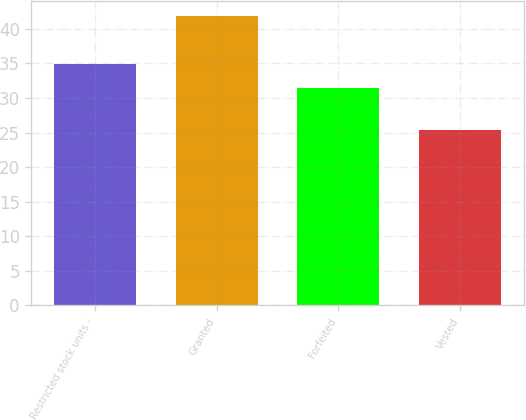Convert chart to OTSL. <chart><loc_0><loc_0><loc_500><loc_500><bar_chart><fcel>Restricted stock units -<fcel>Granted<fcel>Forfeited<fcel>Vested<nl><fcel>34.92<fcel>41.9<fcel>31.44<fcel>25.3<nl></chart> 